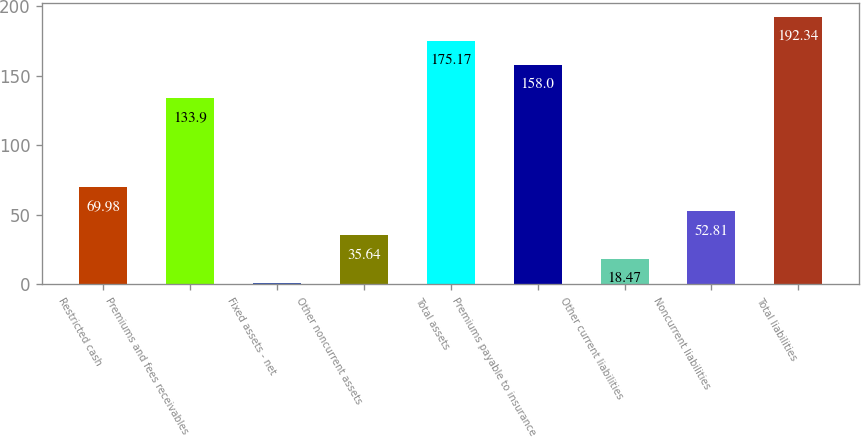Convert chart. <chart><loc_0><loc_0><loc_500><loc_500><bar_chart><fcel>Restricted cash<fcel>Premiums and fees receivables<fcel>Fixed assets - net<fcel>Other noncurrent assets<fcel>Total assets<fcel>Premiums payable to insurance<fcel>Other current liabilities<fcel>Noncurrent liabilities<fcel>Total liabilities<nl><fcel>69.98<fcel>133.9<fcel>1.3<fcel>35.64<fcel>175.17<fcel>158<fcel>18.47<fcel>52.81<fcel>192.34<nl></chart> 